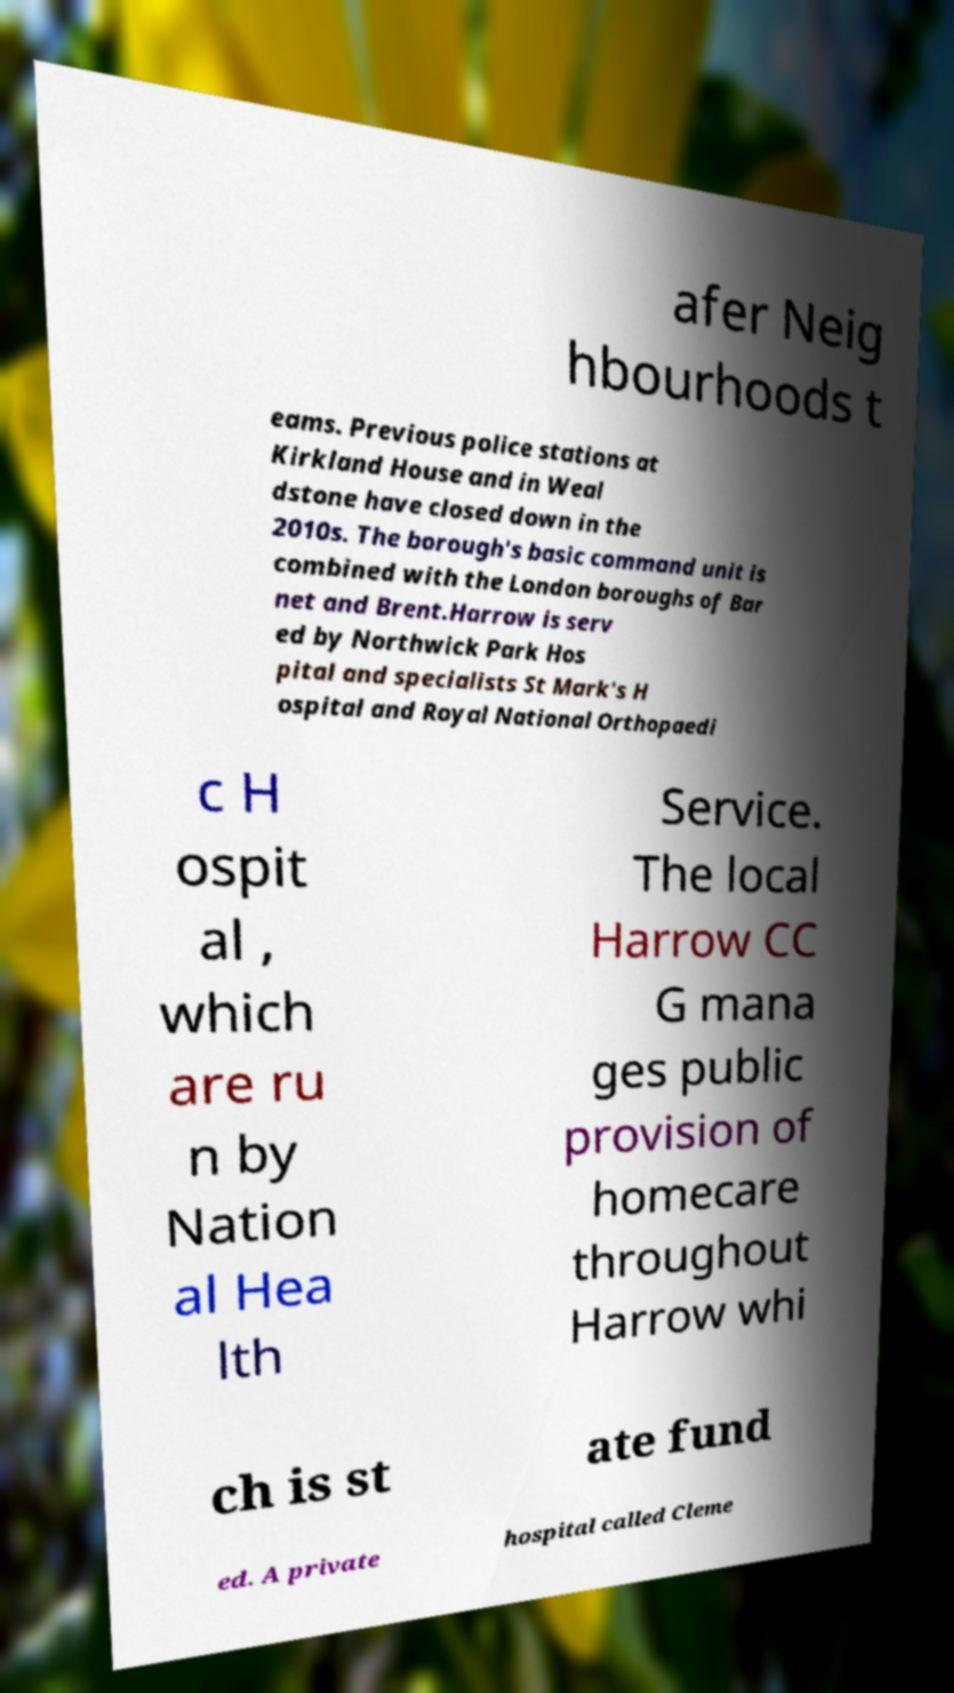I need the written content from this picture converted into text. Can you do that? afer Neig hbourhoods t eams. Previous police stations at Kirkland House and in Weal dstone have closed down in the 2010s. The borough's basic command unit is combined with the London boroughs of Bar net and Brent.Harrow is serv ed by Northwick Park Hos pital and specialists St Mark's H ospital and Royal National Orthopaedi c H ospit al , which are ru n by Nation al Hea lth Service. The local Harrow CC G mana ges public provision of homecare throughout Harrow whi ch is st ate fund ed. A private hospital called Cleme 